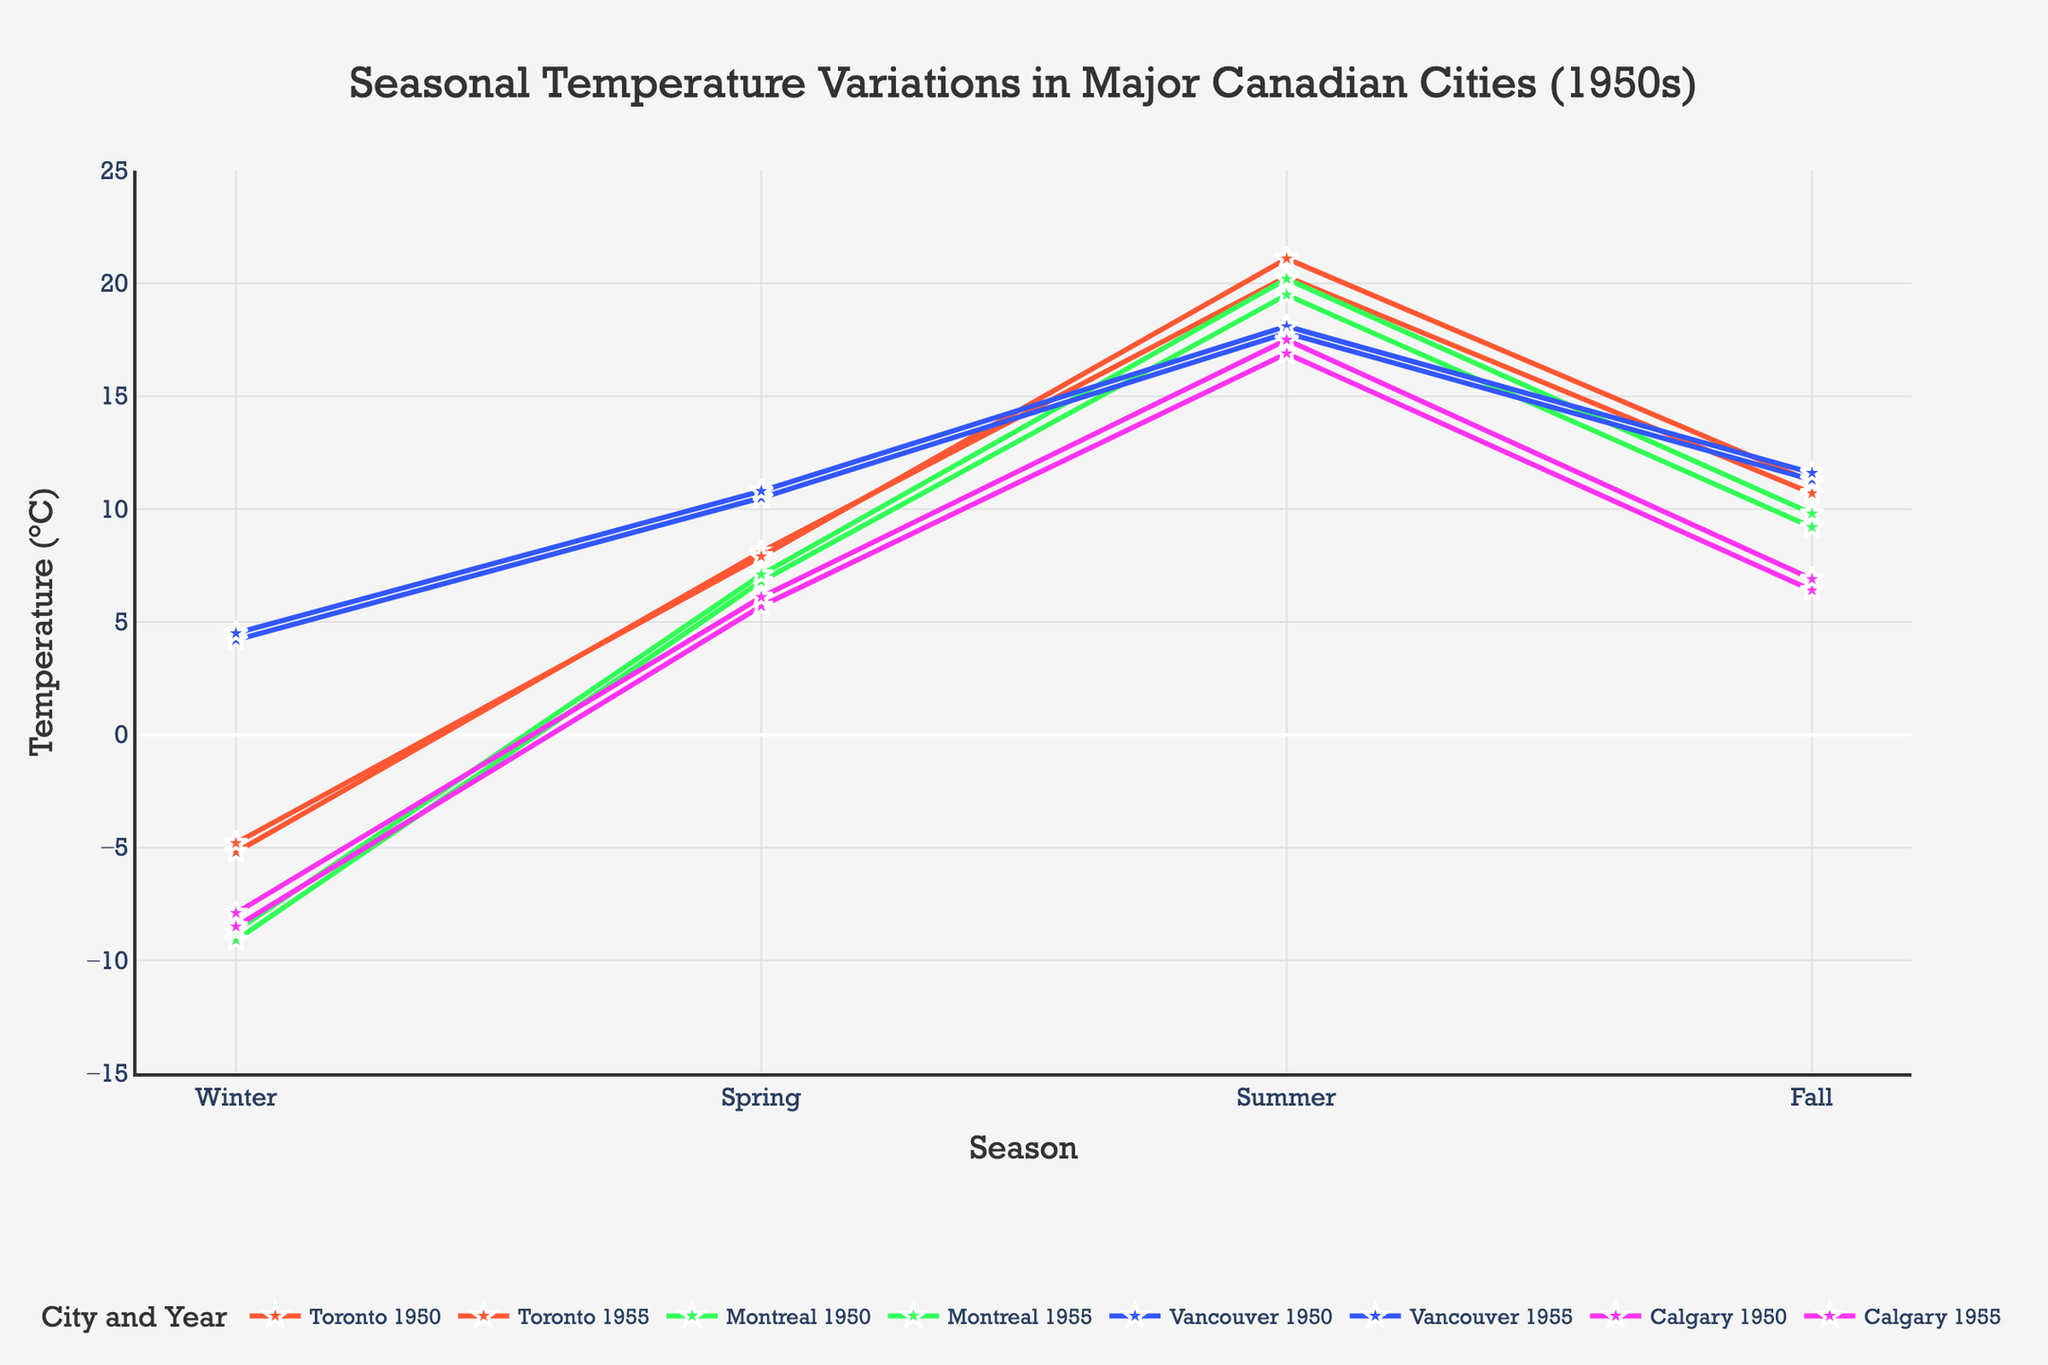What is the temperature difference between Summer and Winter in Toronto in 1950? First, find the Summer temperature for Toronto in 1950, which is 20.3°C, and the Winter temperature, which is -5.2°C. Then calculate the difference: 20.3 - (-5.2) = 25.5°C
Answer: 25.5°C Which city had the highest Summer temperature in 1955? Compare the Summer temperatures in 1955 for all cities: Toronto (21.1°C), Montreal (20.2°C), Vancouver (18.1°C), and Calgary (17.5°C). The highest value is 21.1°C in Toronto.
Answer: Toronto What is the average Winter temperature for all cities in 1950? Add the Winter temperatures for each city in 1950: Toronto (-5.2°C), Montreal (-9.1°C), Vancouver (4.2°C), Calgary (-8.5°C). The sum is -18.6°C. Then, divide by the number of cities: -18.6 / 4 = -4.65°C
Answer: -4.65°C How much did the Fall temperature in Montreal increase from 1950 to 1955? Find the Fall temperature in Montreal for 1950 (9.2°C) and 1955 (9.8°C). Calculate the increase: 9.8 - 9.2 = 0.6°C
Answer: 0.6°C In which season did Vancouver experience the highest temperature in the 1950s, and what was it? Look at the temperatures for each season in Vancouver during the 1950s: Winter 1950 (4.2°C), Spring 1950 (10.5°C), Summer 1950 (17.8°C), Fall 1950 (11.3°C), Winter 1955 (4.5°C), Spring 1955 (10.8°C), Summer 1955 (18.1°C), Fall 1955 (11.6°C). The highest temperature was in Summer 1955 with 18.1°C.
Answer: Summer 1955, 18.1°C By how much did the average Spring temperature increase from 1950 to 1955 across all cities? First, find the Spring temperatures for 1950: Toronto (8.1°C), Montreal (6.8°C), Vancouver (10.5°C), Calgary (5.7°C). Calculate their average: (8.1 + 6.8 + 10.5 + 5.7)/4 = 7.775°C. Then, find the Spring temperatures for 1955: Toronto (7.9°C), Montreal (7.1°C), Vancouver (10.8°C), Calgary (6.1°C). Calculate their average: (7.9 + 7.1 + 10.8 + 6.1)/4 = 7.975°C. Finally, find the increase: 7.975 - 7.775 = 0.2°C
Answer: 0.2°C Which city experienced the lowest temperature overall in the 1950s, and in which year and season did it occur? Examine all the temperatures and find the lowest value: Toronto Winter 1950 (-5.2°C), Toronto Winter 1955 (-4.8°C), Montreal Winter 1950 (-9.1°C), Montreal Winter 1955 (-8.7°C), Vancouver Winter 1950 (4.2°C), Vancouver Winter 1955 (4.5°C), Calgary Winter 1950 (-8.5°C), Calgary Winter 1955 (-7.9°C). The lowest temperature was in Montreal, Winter 1950 with -9.1°C.
Answer: Montreal, Winter 1950 Compute the overall temperature range experienced by Calgary in the 1950s between seasons and years. Identify the highest and lowest temperatures for Calgary: summer 1955 (17.5°C) and winter 1950 (-8.5°C). Calculate the range: 17.5 - (-8.5) = 26.0°C
Answer: 26.0°C 